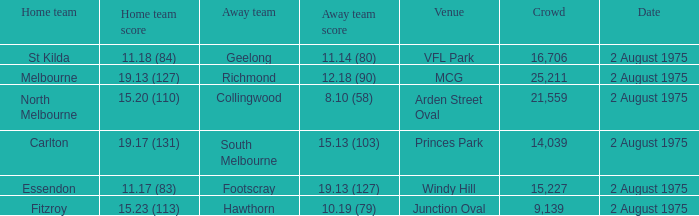How many people attended the game at VFL Park? 16706.0. 